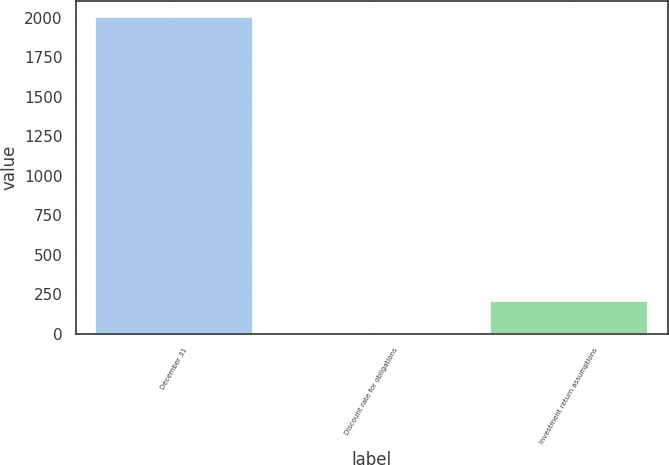<chart> <loc_0><loc_0><loc_500><loc_500><bar_chart><fcel>December 31<fcel>Discount rate for obligations<fcel>Investment return assumptions<nl><fcel>2006<fcel>5.75<fcel>205.78<nl></chart> 